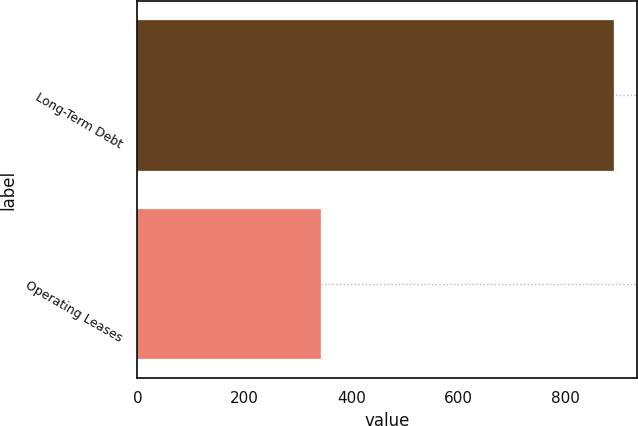Convert chart to OTSL. <chart><loc_0><loc_0><loc_500><loc_500><bar_chart><fcel>Long-Term Debt<fcel>Operating Leases<nl><fcel>890<fcel>344<nl></chart> 